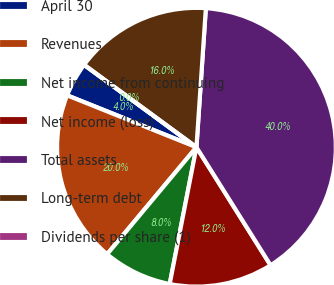<chart> <loc_0><loc_0><loc_500><loc_500><pie_chart><fcel>April 30<fcel>Revenues<fcel>Net income from continuing<fcel>Net income (loss)<fcel>Total assets<fcel>Long-term debt<fcel>Dividends per share (1)<nl><fcel>4.0%<fcel>20.0%<fcel>8.0%<fcel>12.0%<fcel>40.0%<fcel>16.0%<fcel>0.0%<nl></chart> 